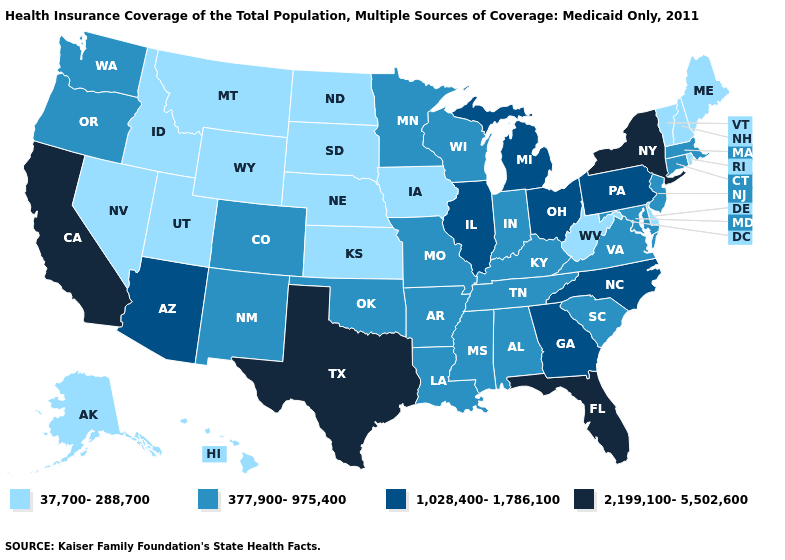Name the states that have a value in the range 2,199,100-5,502,600?
Quick response, please. California, Florida, New York, Texas. Among the states that border West Virginia , does Pennsylvania have the highest value?
Quick response, please. Yes. What is the value of Ohio?
Quick response, please. 1,028,400-1,786,100. What is the highest value in the South ?
Concise answer only. 2,199,100-5,502,600. Name the states that have a value in the range 37,700-288,700?
Write a very short answer. Alaska, Delaware, Hawaii, Idaho, Iowa, Kansas, Maine, Montana, Nebraska, Nevada, New Hampshire, North Dakota, Rhode Island, South Dakota, Utah, Vermont, West Virginia, Wyoming. Does the map have missing data?
Give a very brief answer. No. Name the states that have a value in the range 1,028,400-1,786,100?
Give a very brief answer. Arizona, Georgia, Illinois, Michigan, North Carolina, Ohio, Pennsylvania. Which states have the lowest value in the South?
Give a very brief answer. Delaware, West Virginia. Name the states that have a value in the range 37,700-288,700?
Give a very brief answer. Alaska, Delaware, Hawaii, Idaho, Iowa, Kansas, Maine, Montana, Nebraska, Nevada, New Hampshire, North Dakota, Rhode Island, South Dakota, Utah, Vermont, West Virginia, Wyoming. Does Vermont have the same value as Idaho?
Answer briefly. Yes. Does the map have missing data?
Give a very brief answer. No. Among the states that border North Dakota , which have the highest value?
Give a very brief answer. Minnesota. What is the lowest value in the West?
Concise answer only. 37,700-288,700. Does Delaware have a higher value than Oklahoma?
Write a very short answer. No. Name the states that have a value in the range 1,028,400-1,786,100?
Quick response, please. Arizona, Georgia, Illinois, Michigan, North Carolina, Ohio, Pennsylvania. 